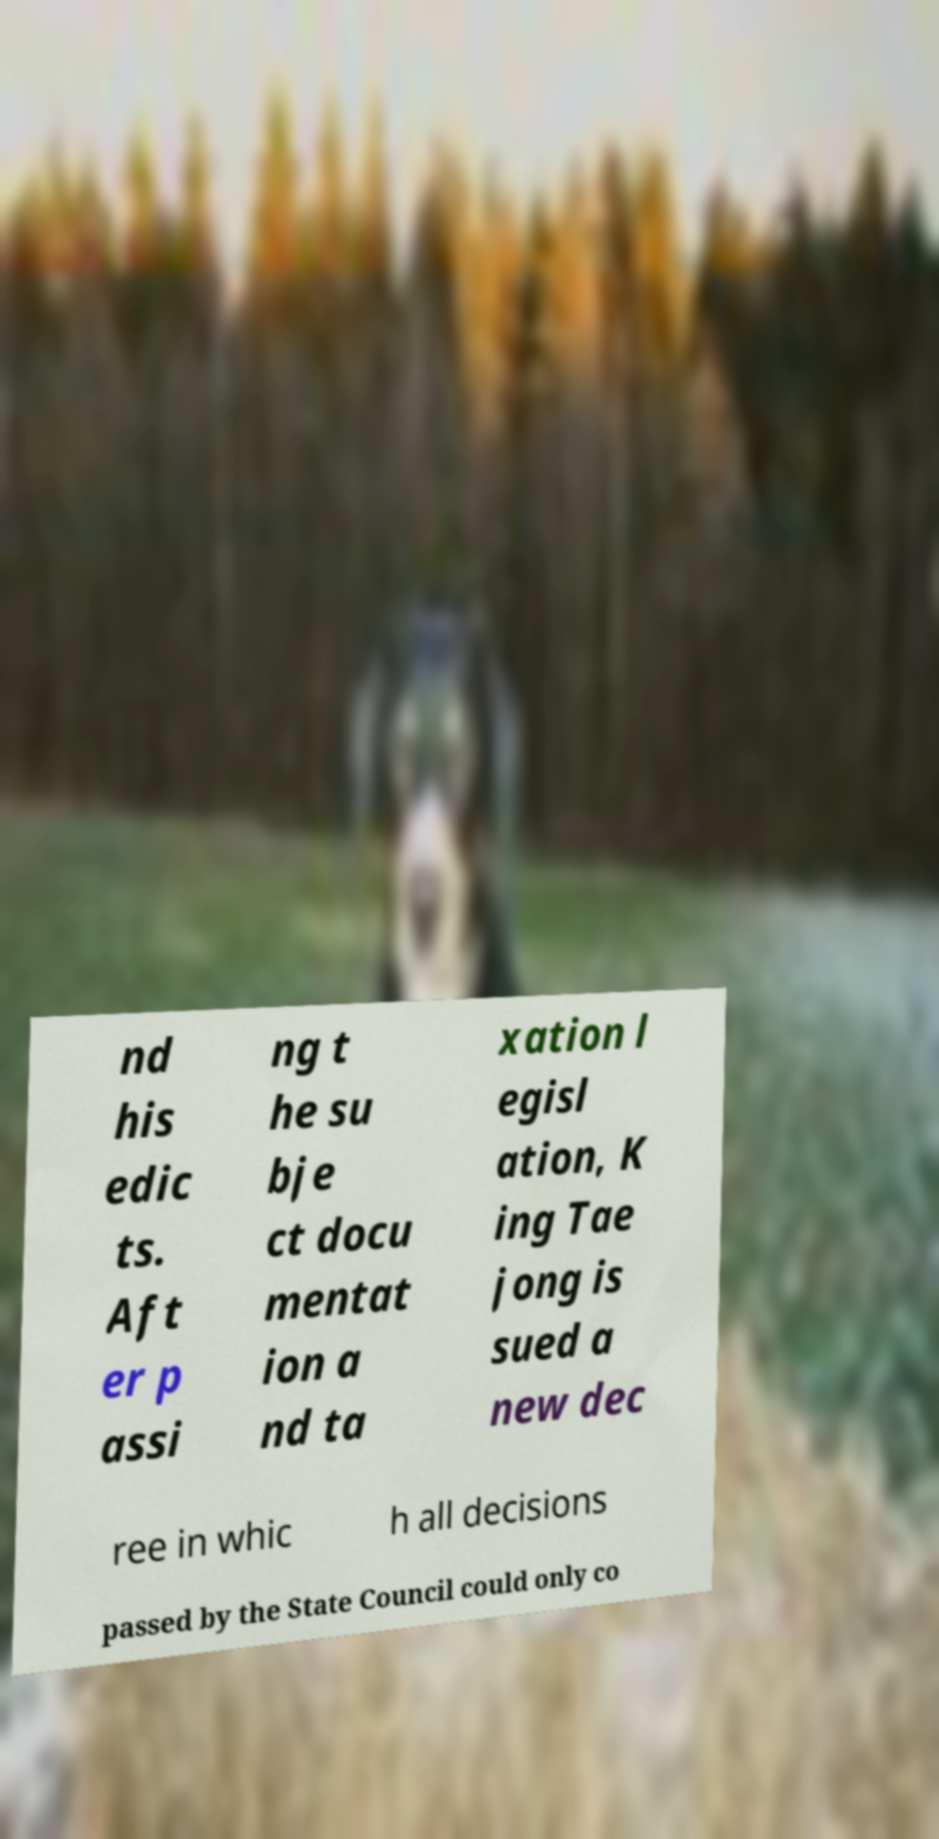Please identify and transcribe the text found in this image. nd his edic ts. Aft er p assi ng t he su bje ct docu mentat ion a nd ta xation l egisl ation, K ing Tae jong is sued a new dec ree in whic h all decisions passed by the State Council could only co 